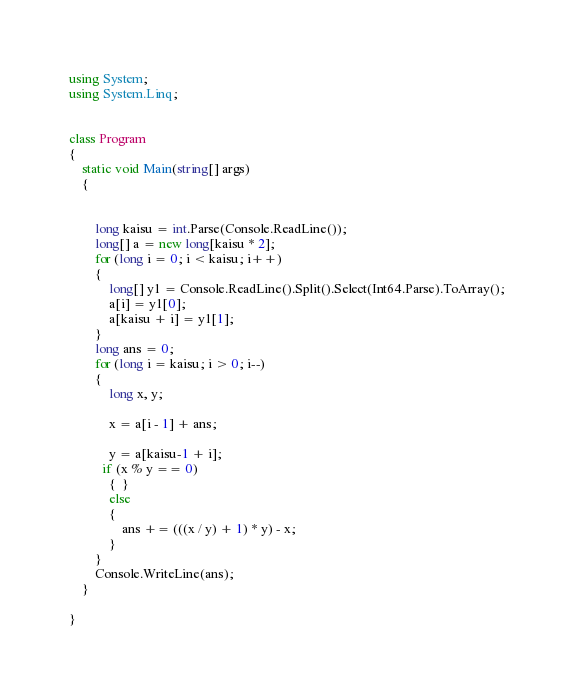<code> <loc_0><loc_0><loc_500><loc_500><_C#_>using System;
using System.Linq;


class Program
{
    static void Main(string[] args)
    {


        long kaisu = int.Parse(Console.ReadLine());
        long[] a = new long[kaisu * 2];
        for (long i = 0; i < kaisu; i++)
        {
            long[] y1 = Console.ReadLine().Split().Select(Int64.Parse).ToArray();
            a[i] = y1[0];
            a[kaisu + i] = y1[1];
        }
        long ans = 0;
        for (long i = kaisu; i > 0; i--)
        {
            long x, y;

            x = a[i - 1] + ans;

            y = a[kaisu-1 + i];
          if (x % y == 0)
            {  }
            else
            {
                ans += (((x / y) + 1) * y) - x;
            }
        }
        Console.WriteLine(ans);
    }

}</code> 